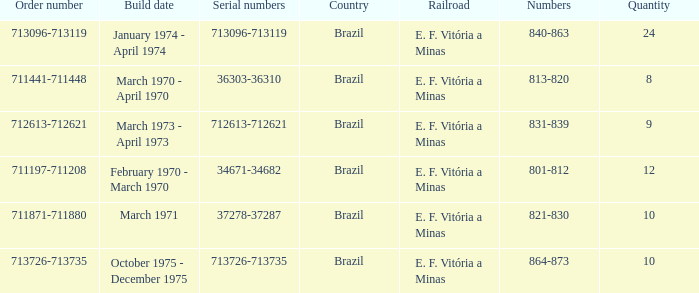The numbers 801-812 are in which country? Brazil. 